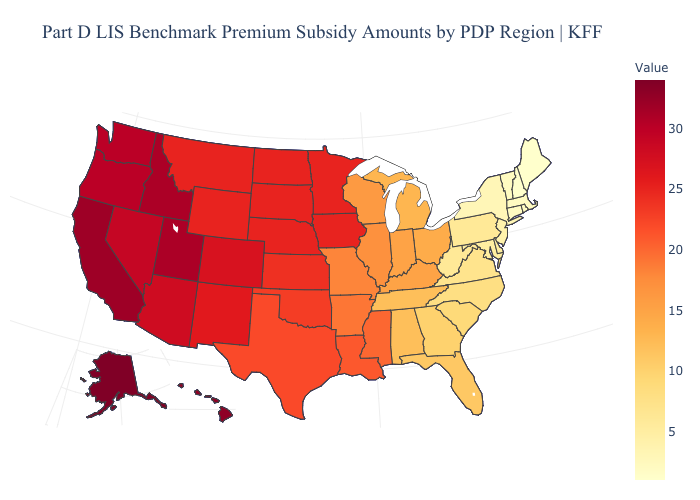Among the states that border Vermont , does New Hampshire have the lowest value?
Quick response, please. Yes. Does Rhode Island have the highest value in the USA?
Concise answer only. No. Which states hav the highest value in the Northeast?
Be succinct. Pennsylvania. 